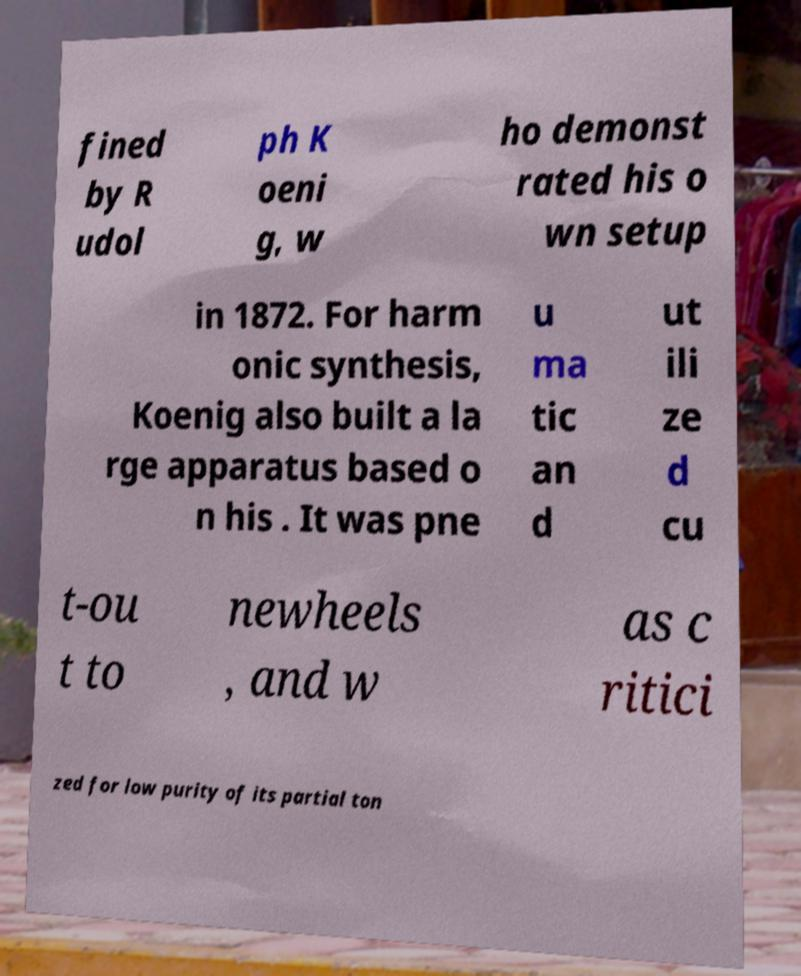There's text embedded in this image that I need extracted. Can you transcribe it verbatim? fined by R udol ph K oeni g, w ho demonst rated his o wn setup in 1872. For harm onic synthesis, Koenig also built a la rge apparatus based o n his . It was pne u ma tic an d ut ili ze d cu t-ou t to newheels , and w as c ritici zed for low purity of its partial ton 